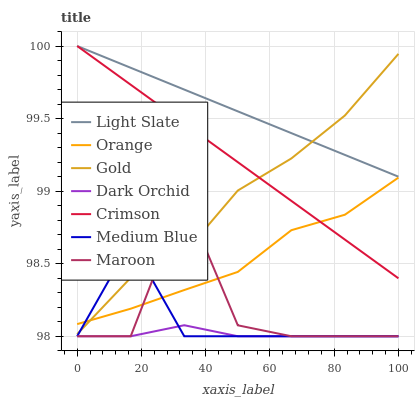Does Dark Orchid have the minimum area under the curve?
Answer yes or no. Yes. Does Light Slate have the maximum area under the curve?
Answer yes or no. Yes. Does Medium Blue have the minimum area under the curve?
Answer yes or no. No. Does Medium Blue have the maximum area under the curve?
Answer yes or no. No. Is Light Slate the smoothest?
Answer yes or no. Yes. Is Maroon the roughest?
Answer yes or no. Yes. Is Medium Blue the smoothest?
Answer yes or no. No. Is Medium Blue the roughest?
Answer yes or no. No. Does Medium Blue have the lowest value?
Answer yes or no. Yes. Does Light Slate have the lowest value?
Answer yes or no. No. Does Crimson have the highest value?
Answer yes or no. Yes. Does Medium Blue have the highest value?
Answer yes or no. No. Is Medium Blue less than Light Slate?
Answer yes or no. Yes. Is Crimson greater than Dark Orchid?
Answer yes or no. Yes. Does Medium Blue intersect Gold?
Answer yes or no. Yes. Is Medium Blue less than Gold?
Answer yes or no. No. Is Medium Blue greater than Gold?
Answer yes or no. No. Does Medium Blue intersect Light Slate?
Answer yes or no. No. 